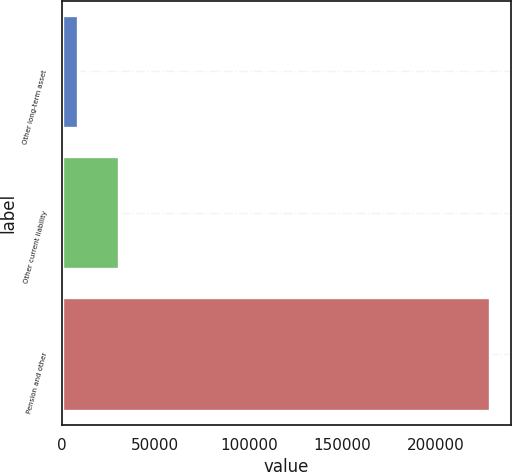Convert chart to OTSL. <chart><loc_0><loc_0><loc_500><loc_500><bar_chart><fcel>Other long-term asset<fcel>Other current liability<fcel>Pension and other<nl><fcel>8573<fcel>30573.6<fcel>228579<nl></chart> 